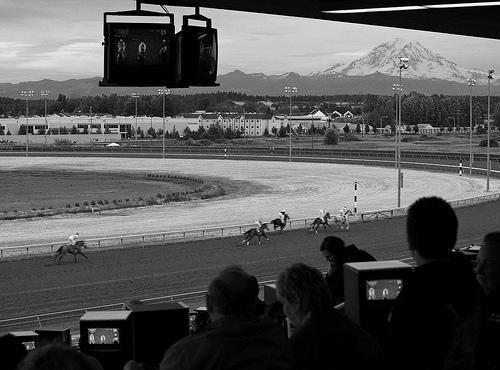How many people are standing up?
Give a very brief answer. 2. 